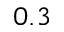Convert formula to latex. <formula><loc_0><loc_0><loc_500><loc_500>0 . 3</formula> 